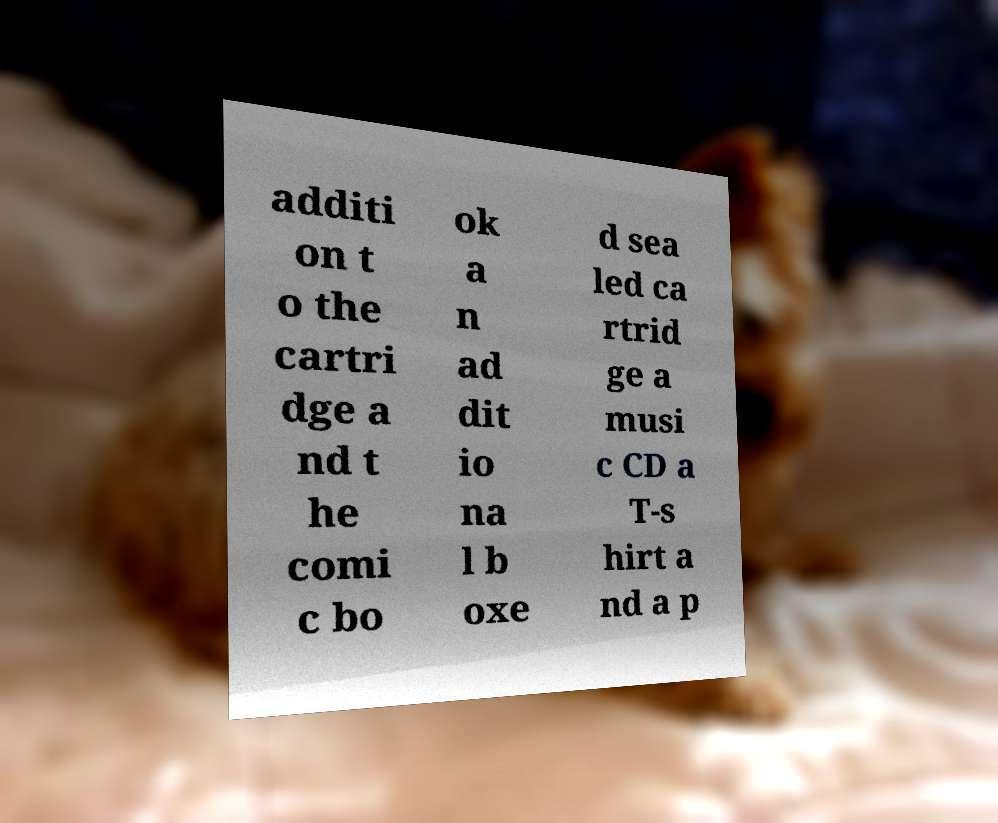Please read and relay the text visible in this image. What does it say? additi on t o the cartri dge a nd t he comi c bo ok a n ad dit io na l b oxe d sea led ca rtrid ge a musi c CD a T-s hirt a nd a p 